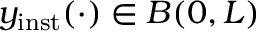Convert formula to latex. <formula><loc_0><loc_0><loc_500><loc_500>y _ { i n s t } ( \cdot ) \in B ( 0 , L )</formula> 